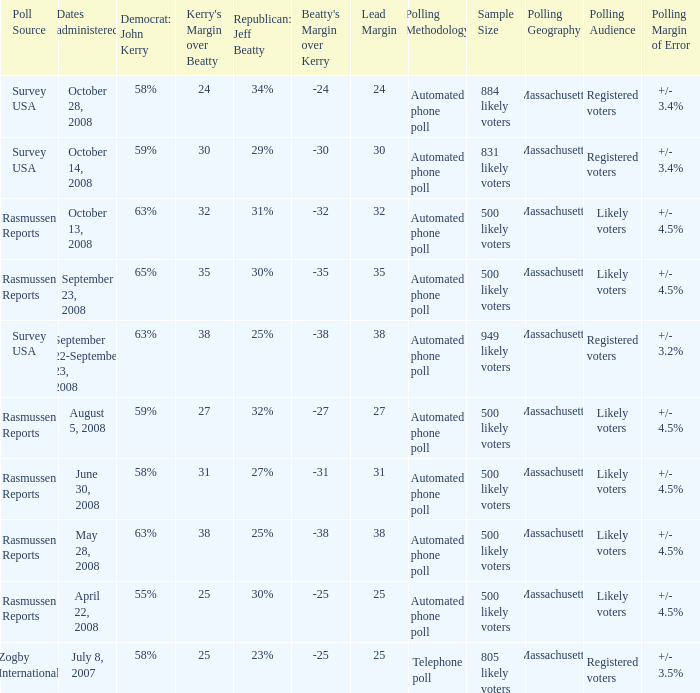What percent is the lead margin of 25 that Republican: Jeff Beatty has according to poll source Rasmussen Reports? 30%. Can you give me this table as a dict? {'header': ['Poll Source', 'Dates administered', 'Democrat: John Kerry', "Kerry's Margin over Beatty", 'Republican: Jeff Beatty', "Beatty's Margin over Kerry", 'Lead Margin', 'Polling Methodology', 'Sample Size', 'Polling Geography', 'Polling Audience', 'Polling Margin of Error'], 'rows': [['Survey USA', 'October 28, 2008', '58%', '24', '34%', '-24', '24', 'Automated phone poll', '884 likely voters', 'Massachusetts ', 'Registered voters', '+/- 3.4%'], ['Survey USA', 'October 14, 2008', '59%', '30', '29%', '-30', '30', 'Automated phone poll', '831 likely voters', 'Massachusetts', 'Registered voters', '+/- 3.4%'], ['Rasmussen Reports', 'October 13, 2008', '63%', '32', '31%', '-32', '32', 'Automated phone poll', '500 likely voters', 'Massachusetts', 'Likely voters', '+/- 4.5%'], ['Rasmussen Reports', 'September 23, 2008', '65%', '35', '30%', '-35', '35', 'Automated phone poll', '500 likely voters', 'Massachusetts', 'Likely voters', '+/- 4.5%'], ['Survey USA', 'September 22-September 23, 2008', '63%', '38', '25%', '-38', '38', 'Automated phone poll', '949 likely voters', 'Massachusetts', 'Registered voters', '+/- 3.2%'], ['Rasmussen Reports', 'August 5, 2008', '59%', '27', '32%', '-27', '27', 'Automated phone poll', '500 likely voters', 'Massachusetts', 'Likely voters', '+/- 4.5%'], ['Rasmussen Reports', 'June 30, 2008', '58%', '31', '27%', '-31', '31', 'Automated phone poll', '500 likely voters', 'Massachusetts', 'Likely voters', '+/- 4.5%'], ['Rasmussen Reports', 'May 28, 2008', '63%', '38', '25%', '-38', '38', 'Automated phone poll', '500 likely voters', 'Massachusetts', 'Likely voters', '+/- 4.5%'], ['Rasmussen Reports', 'April 22, 2008', '55%', '25', '30%', '-25', '25', 'Automated phone poll', '500 likely voters', 'Massachusetts', 'Likely voters', '+/- 4.5%'], ['Zogby International', 'July 8, 2007', '58%', '25', '23%', '-25', '25', 'Telephone poll', '805 likely voters', 'Massachusetts', 'Registered voters', '+/- 3.5%']]} 